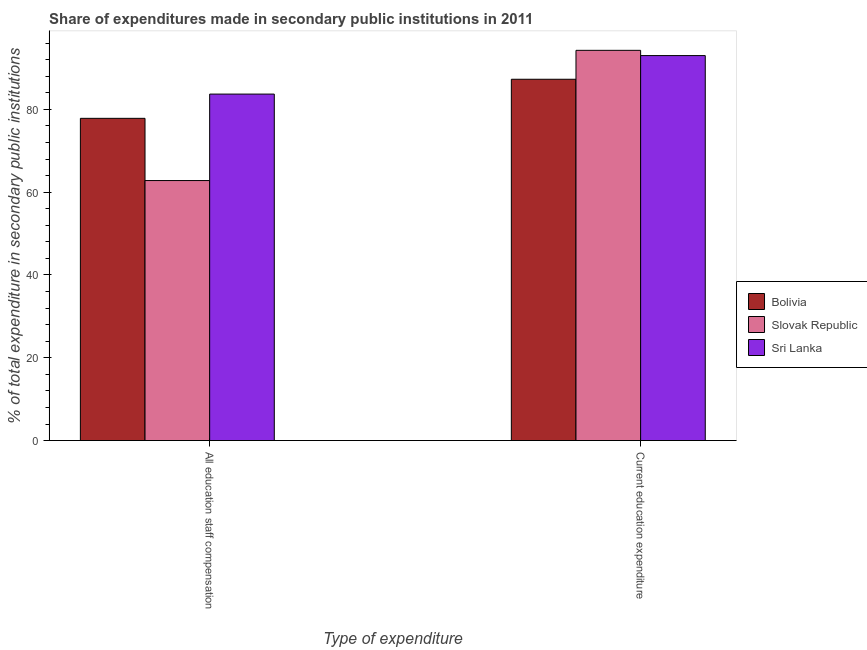How many different coloured bars are there?
Offer a very short reply. 3. How many groups of bars are there?
Offer a terse response. 2. Are the number of bars per tick equal to the number of legend labels?
Give a very brief answer. Yes. How many bars are there on the 1st tick from the right?
Give a very brief answer. 3. What is the label of the 2nd group of bars from the left?
Your answer should be very brief. Current education expenditure. What is the expenditure in staff compensation in Bolivia?
Make the answer very short. 77.83. Across all countries, what is the maximum expenditure in staff compensation?
Your response must be concise. 83.68. Across all countries, what is the minimum expenditure in education?
Provide a short and direct response. 87.27. In which country was the expenditure in education maximum?
Offer a very short reply. Slovak Republic. In which country was the expenditure in education minimum?
Offer a very short reply. Bolivia. What is the total expenditure in education in the graph?
Your answer should be compact. 274.5. What is the difference between the expenditure in education in Sri Lanka and that in Slovak Republic?
Your answer should be compact. -1.27. What is the difference between the expenditure in education in Slovak Republic and the expenditure in staff compensation in Sri Lanka?
Your answer should be very brief. 10.57. What is the average expenditure in education per country?
Ensure brevity in your answer.  91.5. What is the difference between the expenditure in education and expenditure in staff compensation in Slovak Republic?
Your response must be concise. 31.45. What is the ratio of the expenditure in staff compensation in Sri Lanka to that in Bolivia?
Make the answer very short. 1.08. What does the 3rd bar from the left in Current education expenditure represents?
Provide a short and direct response. Sri Lanka. What does the 1st bar from the right in Current education expenditure represents?
Ensure brevity in your answer.  Sri Lanka. Are all the bars in the graph horizontal?
Give a very brief answer. No. How many countries are there in the graph?
Your answer should be very brief. 3. Where does the legend appear in the graph?
Your answer should be compact. Center right. What is the title of the graph?
Provide a succinct answer. Share of expenditures made in secondary public institutions in 2011. What is the label or title of the X-axis?
Provide a succinct answer. Type of expenditure. What is the label or title of the Y-axis?
Offer a very short reply. % of total expenditure in secondary public institutions. What is the % of total expenditure in secondary public institutions of Bolivia in All education staff compensation?
Your response must be concise. 77.83. What is the % of total expenditure in secondary public institutions in Slovak Republic in All education staff compensation?
Make the answer very short. 62.8. What is the % of total expenditure in secondary public institutions of Sri Lanka in All education staff compensation?
Give a very brief answer. 83.68. What is the % of total expenditure in secondary public institutions of Bolivia in Current education expenditure?
Your response must be concise. 87.27. What is the % of total expenditure in secondary public institutions of Slovak Republic in Current education expenditure?
Keep it short and to the point. 94.25. What is the % of total expenditure in secondary public institutions of Sri Lanka in Current education expenditure?
Make the answer very short. 92.98. Across all Type of expenditure, what is the maximum % of total expenditure in secondary public institutions in Bolivia?
Offer a terse response. 87.27. Across all Type of expenditure, what is the maximum % of total expenditure in secondary public institutions in Slovak Republic?
Your answer should be compact. 94.25. Across all Type of expenditure, what is the maximum % of total expenditure in secondary public institutions in Sri Lanka?
Keep it short and to the point. 92.98. Across all Type of expenditure, what is the minimum % of total expenditure in secondary public institutions in Bolivia?
Ensure brevity in your answer.  77.83. Across all Type of expenditure, what is the minimum % of total expenditure in secondary public institutions of Slovak Republic?
Give a very brief answer. 62.8. Across all Type of expenditure, what is the minimum % of total expenditure in secondary public institutions of Sri Lanka?
Keep it short and to the point. 83.68. What is the total % of total expenditure in secondary public institutions of Bolivia in the graph?
Your response must be concise. 165.09. What is the total % of total expenditure in secondary public institutions in Slovak Republic in the graph?
Your response must be concise. 157.05. What is the total % of total expenditure in secondary public institutions in Sri Lanka in the graph?
Your answer should be compact. 176.67. What is the difference between the % of total expenditure in secondary public institutions of Bolivia in All education staff compensation and that in Current education expenditure?
Your answer should be compact. -9.44. What is the difference between the % of total expenditure in secondary public institutions in Slovak Republic in All education staff compensation and that in Current education expenditure?
Make the answer very short. -31.45. What is the difference between the % of total expenditure in secondary public institutions in Sri Lanka in All education staff compensation and that in Current education expenditure?
Make the answer very short. -9.3. What is the difference between the % of total expenditure in secondary public institutions of Bolivia in All education staff compensation and the % of total expenditure in secondary public institutions of Slovak Republic in Current education expenditure?
Offer a terse response. -16.42. What is the difference between the % of total expenditure in secondary public institutions of Bolivia in All education staff compensation and the % of total expenditure in secondary public institutions of Sri Lanka in Current education expenditure?
Offer a very short reply. -15.15. What is the difference between the % of total expenditure in secondary public institutions of Slovak Republic in All education staff compensation and the % of total expenditure in secondary public institutions of Sri Lanka in Current education expenditure?
Make the answer very short. -30.18. What is the average % of total expenditure in secondary public institutions of Bolivia per Type of expenditure?
Make the answer very short. 82.55. What is the average % of total expenditure in secondary public institutions in Slovak Republic per Type of expenditure?
Your answer should be compact. 78.52. What is the average % of total expenditure in secondary public institutions of Sri Lanka per Type of expenditure?
Keep it short and to the point. 88.33. What is the difference between the % of total expenditure in secondary public institutions of Bolivia and % of total expenditure in secondary public institutions of Slovak Republic in All education staff compensation?
Provide a succinct answer. 15.03. What is the difference between the % of total expenditure in secondary public institutions in Bolivia and % of total expenditure in secondary public institutions in Sri Lanka in All education staff compensation?
Your answer should be very brief. -5.86. What is the difference between the % of total expenditure in secondary public institutions of Slovak Republic and % of total expenditure in secondary public institutions of Sri Lanka in All education staff compensation?
Your answer should be very brief. -20.88. What is the difference between the % of total expenditure in secondary public institutions in Bolivia and % of total expenditure in secondary public institutions in Slovak Republic in Current education expenditure?
Your response must be concise. -6.98. What is the difference between the % of total expenditure in secondary public institutions in Bolivia and % of total expenditure in secondary public institutions in Sri Lanka in Current education expenditure?
Provide a short and direct response. -5.72. What is the difference between the % of total expenditure in secondary public institutions of Slovak Republic and % of total expenditure in secondary public institutions of Sri Lanka in Current education expenditure?
Your answer should be very brief. 1.27. What is the ratio of the % of total expenditure in secondary public institutions in Bolivia in All education staff compensation to that in Current education expenditure?
Your answer should be compact. 0.89. What is the ratio of the % of total expenditure in secondary public institutions in Slovak Republic in All education staff compensation to that in Current education expenditure?
Provide a short and direct response. 0.67. What is the ratio of the % of total expenditure in secondary public institutions of Sri Lanka in All education staff compensation to that in Current education expenditure?
Provide a short and direct response. 0.9. What is the difference between the highest and the second highest % of total expenditure in secondary public institutions of Bolivia?
Your answer should be compact. 9.44. What is the difference between the highest and the second highest % of total expenditure in secondary public institutions in Slovak Republic?
Your answer should be compact. 31.45. What is the difference between the highest and the second highest % of total expenditure in secondary public institutions of Sri Lanka?
Your response must be concise. 9.3. What is the difference between the highest and the lowest % of total expenditure in secondary public institutions of Bolivia?
Ensure brevity in your answer.  9.44. What is the difference between the highest and the lowest % of total expenditure in secondary public institutions of Slovak Republic?
Your answer should be very brief. 31.45. What is the difference between the highest and the lowest % of total expenditure in secondary public institutions of Sri Lanka?
Offer a terse response. 9.3. 